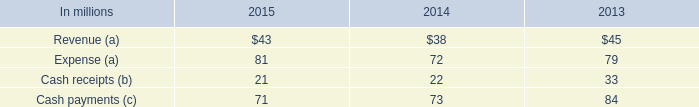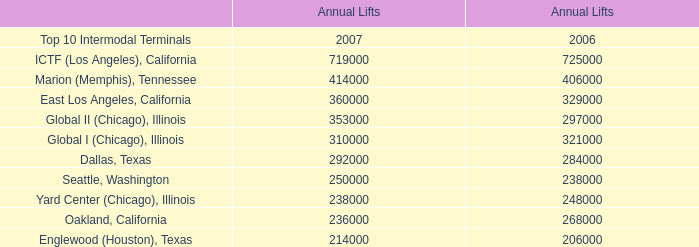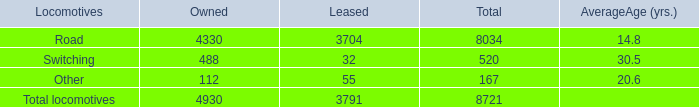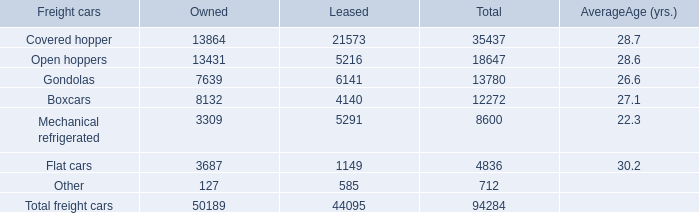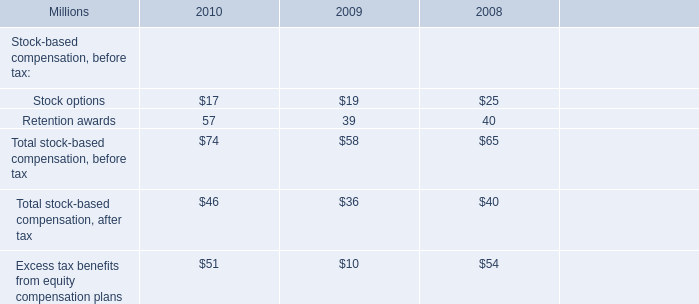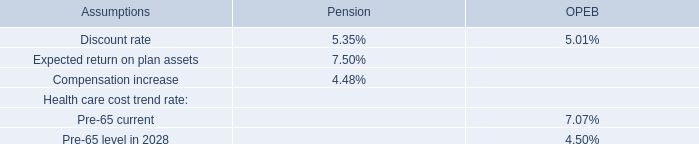What's the total value of all Locomotives that are smaller than 100 in leased? 
Computations: (32 + 55)
Answer: 87.0. 